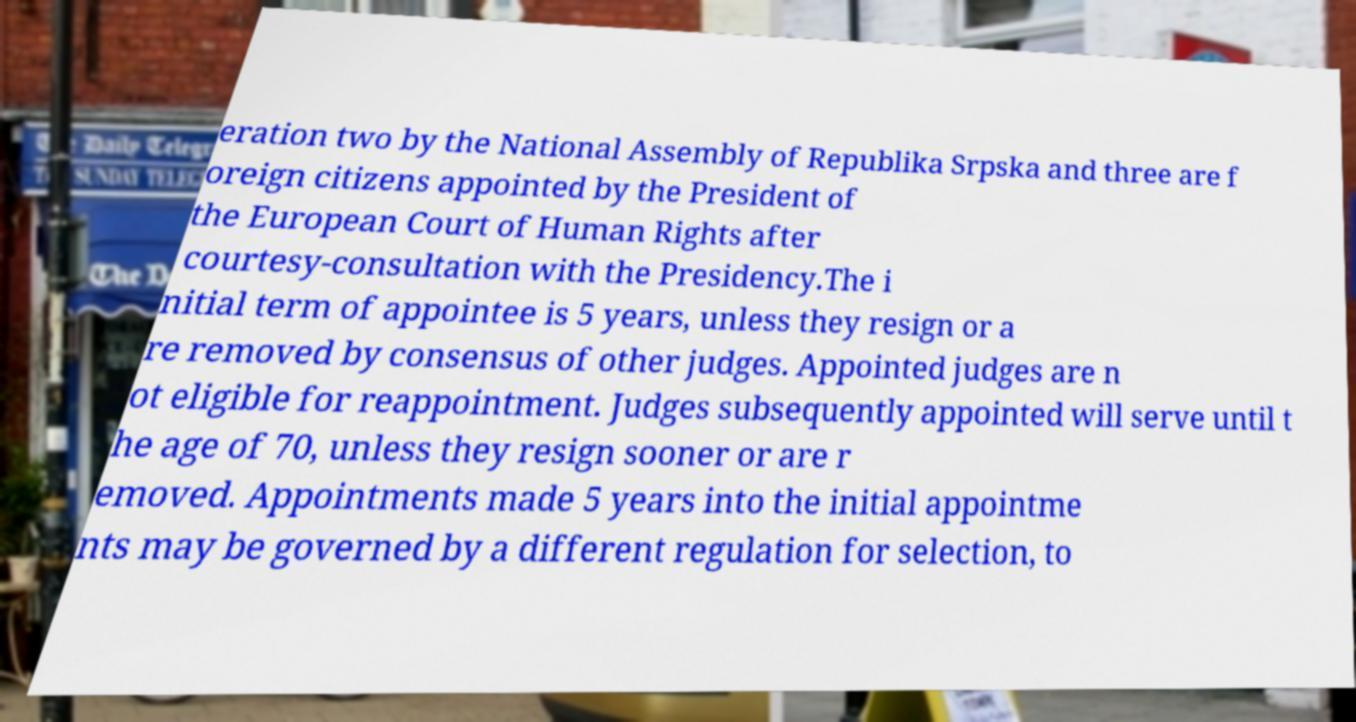Please read and relay the text visible in this image. What does it say? eration two by the National Assembly of Republika Srpska and three are f oreign citizens appointed by the President of the European Court of Human Rights after courtesy-consultation with the Presidency.The i nitial term of appointee is 5 years, unless they resign or a re removed by consensus of other judges. Appointed judges are n ot eligible for reappointment. Judges subsequently appointed will serve until t he age of 70, unless they resign sooner or are r emoved. Appointments made 5 years into the initial appointme nts may be governed by a different regulation for selection, to 